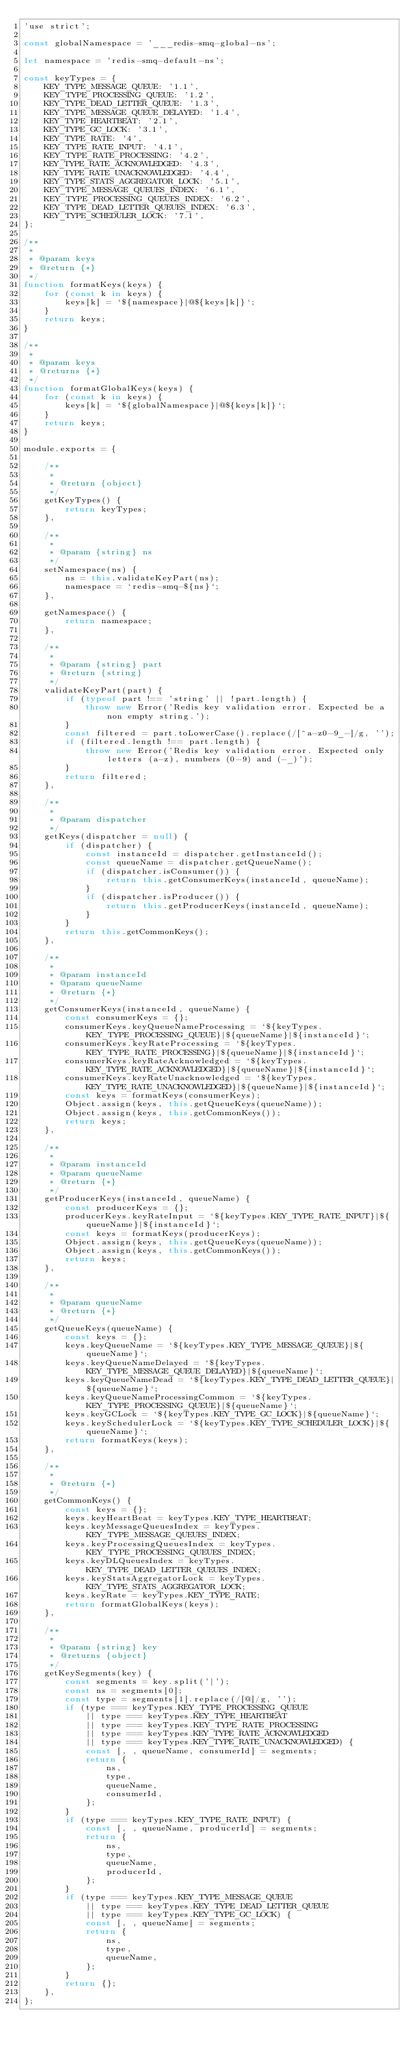Convert code to text. <code><loc_0><loc_0><loc_500><loc_500><_JavaScript_>'use strict';

const globalNamespace = '___redis-smq-global-ns';

let namespace = 'redis-smq-default-ns';

const keyTypes = {
    KEY_TYPE_MESSAGE_QUEUE: '1.1',
    KEY_TYPE_PROCESSING_QUEUE: '1.2',
    KEY_TYPE_DEAD_LETTER_QUEUE: '1.3',
    KEY_TYPE_MESSAGE_QUEUE_DELAYED: '1.4',
    KEY_TYPE_HEARTBEAT: '2.1',
    KEY_TYPE_GC_LOCK: '3.1',
    KEY_TYPE_RATE: '4',
    KEY_TYPE_RATE_INPUT: '4.1',
    KEY_TYPE_RATE_PROCESSING: '4.2',
    KEY_TYPE_RATE_ACKNOWLEDGED: '4.3',
    KEY_TYPE_RATE_UNACKNOWLEDGED: '4.4',
    KEY_TYPE_STATS_AGGREGATOR_LOCK: '5.1',
    KEY_TYPE_MESSAGE_QUEUES_INDEX: '6.1',
    KEY_TYPE_PROCESSING_QUEUES_INDEX: '6.2',
    KEY_TYPE_DEAD_LETTER_QUEUES_INDEX: '6.3',
    KEY_TYPE_SCHEDULER_LOCK: '7.1',
};

/**
 *
 * @param keys
 * @return {*}
 */
function formatKeys(keys) {
    for (const k in keys) {
        keys[k] = `${namespace}|@${keys[k]}`;
    }
    return keys;
}

/**
 *
 * @param keys
 * @returns {*}
 */
function formatGlobalKeys(keys) {
    for (const k in keys) {
        keys[k] = `${globalNamespace}|@${keys[k]}`;
    }
    return keys;
}

module.exports = {

    /**
     * 
     * @return {object}
     */
    getKeyTypes() {
        return keyTypes;
    },

    /**
     *
     * @param {string} ns
     */
    setNamespace(ns) {
        ns = this.validateKeyPart(ns);
        namespace = `redis-smq-${ns}`;
    },

    getNamespace() {
        return namespace;
    },

    /**
     *
     * @param {string} part
     * @return {string}
     */
    validateKeyPart(part) {
        if (typeof part !== 'string' || !part.length) {
            throw new Error('Redis key validation error. Expected be a non empty string.');
        }
        const filtered = part.toLowerCase().replace(/[^a-z0-9_-]/g, '');
        if (filtered.length !== part.length) {
            throw new Error('Redis key validation error. Expected only letters (a-z), numbers (0-9) and (-_)');
        }
        return filtered;
    },

    /**
     *
     * @param dispatcher
     */
    getKeys(dispatcher = null) {
        if (dispatcher) {
            const instanceId = dispatcher.getInstanceId();
            const queueName = dispatcher.getQueueName();
            if (dispatcher.isConsumer()) {
                return this.getConsumerKeys(instanceId, queueName);
            }
            if (dispatcher.isProducer()) {
                return this.getProducerKeys(instanceId, queueName);
            }
        }
        return this.getCommonKeys();
    },

    /**
     *
     * @param instanceId
     * @param queueName
     * @return {*}
     */
    getConsumerKeys(instanceId, queueName) {
        const consumerKeys = {};
        consumerKeys.keyQueueNameProcessing = `${keyTypes.KEY_TYPE_PROCESSING_QUEUE}|${queueName}|${instanceId}`;
        consumerKeys.keyRateProcessing = `${keyTypes.KEY_TYPE_RATE_PROCESSING}|${queueName}|${instanceId}`;
        consumerKeys.keyRateAcknowledged = `${keyTypes.KEY_TYPE_RATE_ACKNOWLEDGED}|${queueName}|${instanceId}`;
        consumerKeys.keyRateUnacknowledged = `${keyTypes.KEY_TYPE_RATE_UNACKNOWLEDGED}|${queueName}|${instanceId}`;
        const keys = formatKeys(consumerKeys);
        Object.assign(keys, this.getQueueKeys(queueName));
        Object.assign(keys, this.getCommonKeys());
        return keys;
    },

    /**
     *
     * @param instanceId
     * @param queueName
     * @return {*}
     */
    getProducerKeys(instanceId, queueName) {
        const producerKeys = {};
        producerKeys.keyRateInput = `${keyTypes.KEY_TYPE_RATE_INPUT}|${queueName}|${instanceId}`;
        const keys = formatKeys(producerKeys);
        Object.assign(keys, this.getQueueKeys(queueName));
        Object.assign(keys, this.getCommonKeys());
        return keys;
    },

    /**
     *
     * @param queueName
     * @return {*}
     */
    getQueueKeys(queueName) {
        const keys = {};
        keys.keyQueueName = `${keyTypes.KEY_TYPE_MESSAGE_QUEUE}|${queueName}`;
        keys.keyQueueNameDelayed = `${keyTypes.KEY_TYPE_MESSAGE_QUEUE_DELAYED}|${queueName}`;
        keys.keyQueueNameDead = `${keyTypes.KEY_TYPE_DEAD_LETTER_QUEUE}|${queueName}`;
        keys.keyQueueNameProcessingCommon = `${keyTypes.KEY_TYPE_PROCESSING_QUEUE}|${queueName}`;
        keys.keyGCLock = `${keyTypes.KEY_TYPE_GC_LOCK}|${queueName}`;
        keys.keySchedulerLock = `${keyTypes.KEY_TYPE_SCHEDULER_LOCK}|${queueName}`;
        return formatKeys(keys);
    },

    /**
     *
     * @return {*}
     */
    getCommonKeys() {
        const keys = {};
        keys.keyHeartBeat = keyTypes.KEY_TYPE_HEARTBEAT;
        keys.keyMessageQueuesIndex = keyTypes.KEY_TYPE_MESSAGE_QUEUES_INDEX;
        keys.keyProcessingQueuesIndex = keyTypes.KEY_TYPE_PROCESSING_QUEUES_INDEX;
        keys.keyDLQueuesIndex = keyTypes.KEY_TYPE_DEAD_LETTER_QUEUES_INDEX;
        keys.keyStatsAggregatorLock = keyTypes.KEY_TYPE_STATS_AGGREGATOR_LOCK;
        keys.keyRate = keyTypes.KEY_TYPE_RATE;
        return formatGlobalKeys(keys);
    },

    /**
     *
     * @param {string} key
     * @returns {object}
     */
    getKeySegments(key) {
        const segments = key.split('|');
        const ns = segments[0];
        const type = segments[1].replace(/[@]/g, '');
        if (type === keyTypes.KEY_TYPE_PROCESSING_QUEUE
            || type === keyTypes.KEY_TYPE_HEARTBEAT
            || type === keyTypes.KEY_TYPE_RATE_PROCESSING
            || type === keyTypes.KEY_TYPE_RATE_ACKNOWLEDGED
            || type === keyTypes.KEY_TYPE_RATE_UNACKNOWLEDGED) {
            const [, , queueName, consumerId] = segments;
            return {
                ns,
                type,
                queueName,
                consumerId,
            };
        }
        if (type === keyTypes.KEY_TYPE_RATE_INPUT) {
            const [, , queueName, producerId] = segments;
            return {
                ns,
                type,
                queueName,
                producerId,
            };
        }
        if (type === keyTypes.KEY_TYPE_MESSAGE_QUEUE
            || type === keyTypes.KEY_TYPE_DEAD_LETTER_QUEUE
            || type === keyTypes.KEY_TYPE_GC_LOCK) {
            const [, , queueName] = segments;
            return {
                ns,
                type,
                queueName,
            };
        }
        return {};
    },
};
</code> 